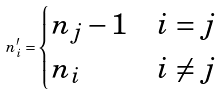Convert formula to latex. <formula><loc_0><loc_0><loc_500><loc_500>n _ { i } ^ { \prime } = \begin{cases} n _ { j } - 1 & i = j \\ n _ { i } & i \not = j \end{cases}</formula> 